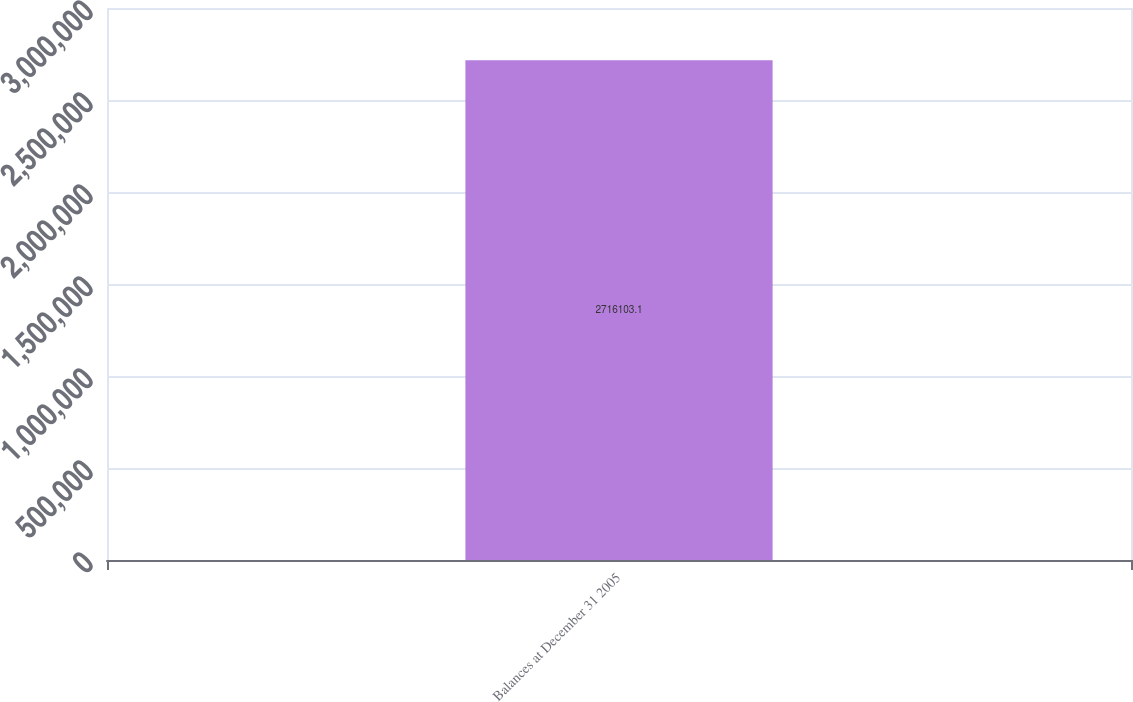<chart> <loc_0><loc_0><loc_500><loc_500><bar_chart><fcel>Balances at December 31 2005<nl><fcel>2.7161e+06<nl></chart> 